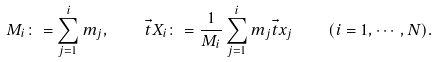Convert formula to latex. <formula><loc_0><loc_0><loc_500><loc_500>M _ { i } \colon = \sum _ { j = 1 } ^ { i } m _ { j } , \quad \vec { t } { X } _ { i } \colon = \frac { 1 } { M _ { i } } \sum _ { j = 1 } ^ { i } m _ { j } \vec { t } { x } _ { j } \quad ( i = 1 , \cdots , N ) .</formula> 